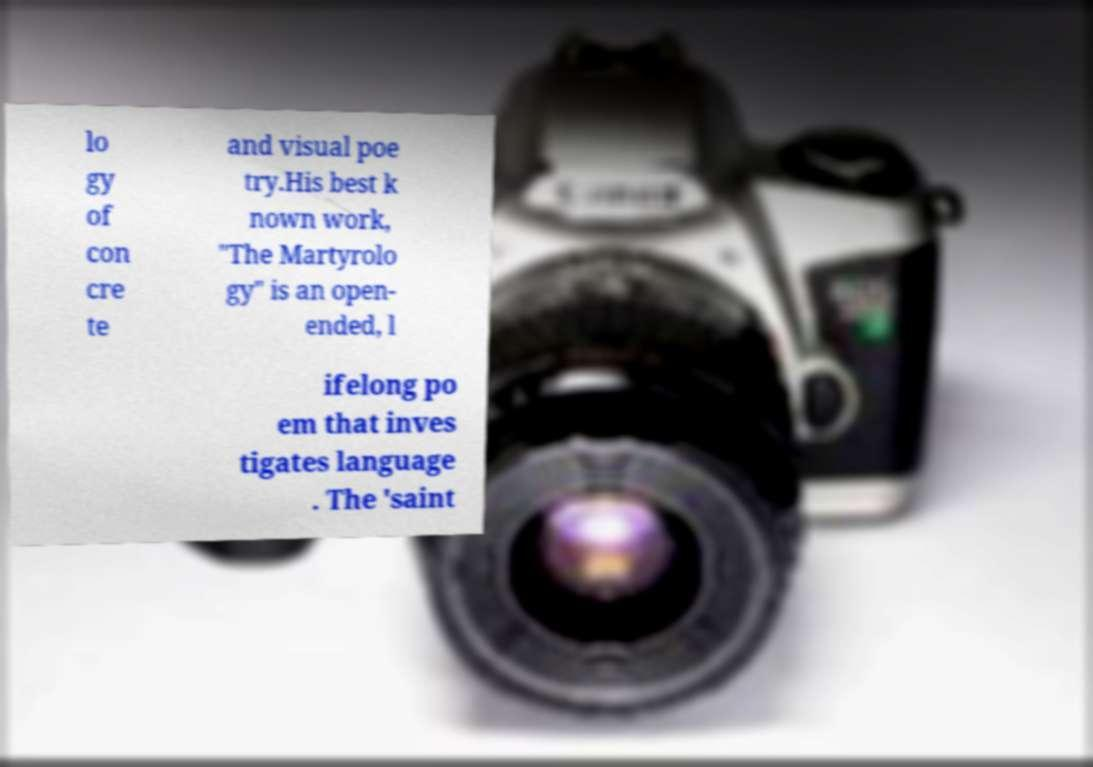Please identify and transcribe the text found in this image. lo gy of con cre te and visual poe try.His best k nown work, "The Martyrolo gy" is an open- ended, l ifelong po em that inves tigates language . The 'saint 